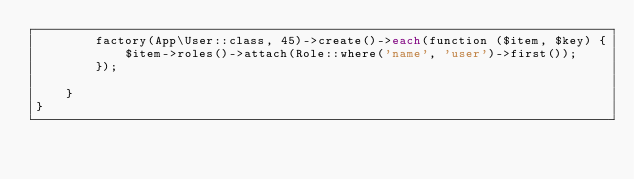<code> <loc_0><loc_0><loc_500><loc_500><_PHP_>		factory(App\User::class, 45)->create()->each(function ($item, $key) {
		    $item->roles()->attach(Role::where('name', 'user')->first());
		});
        
    }
}
</code> 